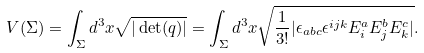<formula> <loc_0><loc_0><loc_500><loc_500>V ( \Sigma ) = \int _ { \Sigma } d ^ { 3 } x \sqrt { | \det ( q ) | } = \int _ { \Sigma } d ^ { 3 } x \sqrt { \frac { 1 } { 3 ! } | \epsilon _ { a b c } \epsilon ^ { i j k } E ^ { a } _ { i } E ^ { b } _ { j } E ^ { c } _ { k } | } .</formula> 